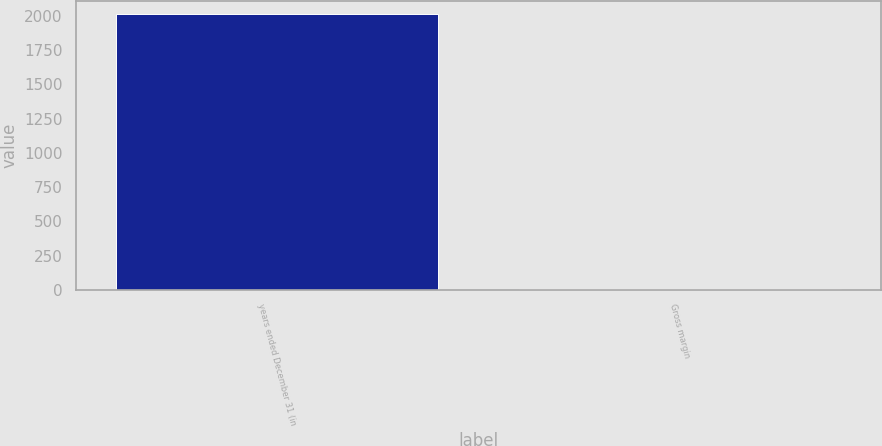Convert chart. <chart><loc_0><loc_0><loc_500><loc_500><bar_chart><fcel>years ended December 31 (in<fcel>Gross margin<nl><fcel>2012<fcel>8<nl></chart> 